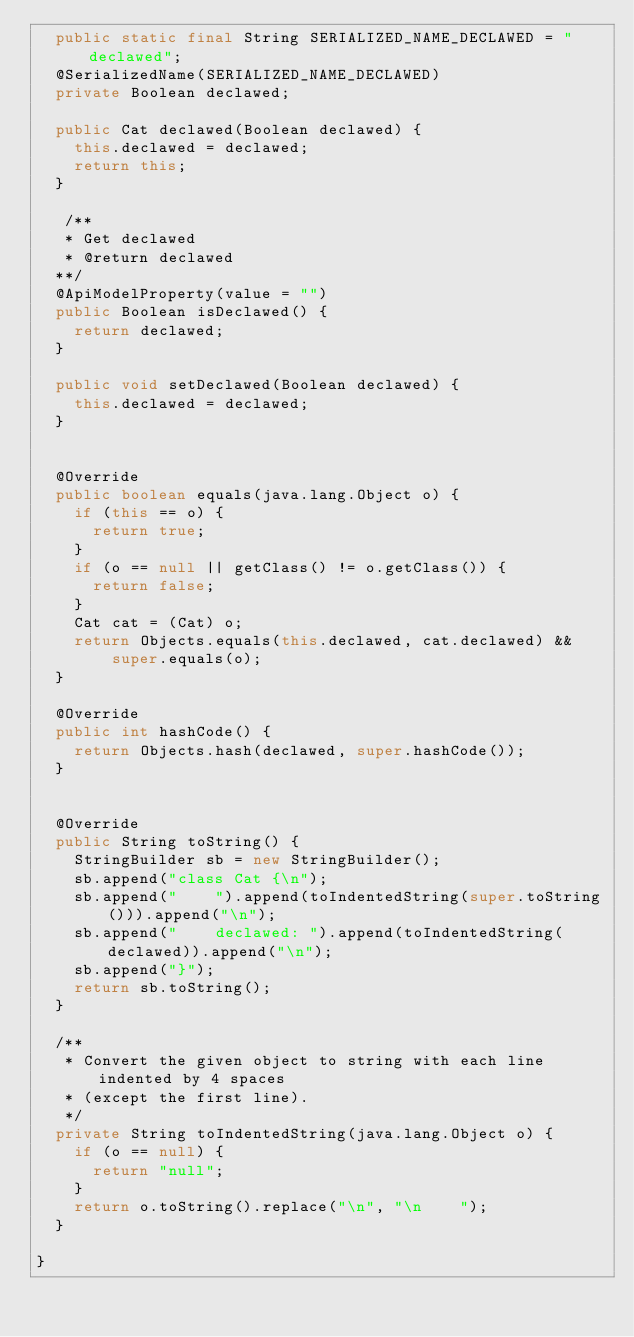Convert code to text. <code><loc_0><loc_0><loc_500><loc_500><_Java_>  public static final String SERIALIZED_NAME_DECLAWED = "declawed";
  @SerializedName(SERIALIZED_NAME_DECLAWED)
  private Boolean declawed;

  public Cat declawed(Boolean declawed) {
    this.declawed = declawed;
    return this;
  }

   /**
   * Get declawed
   * @return declawed
  **/
  @ApiModelProperty(value = "")
  public Boolean isDeclawed() {
    return declawed;
  }

  public void setDeclawed(Boolean declawed) {
    this.declawed = declawed;
  }


  @Override
  public boolean equals(java.lang.Object o) {
    if (this == o) {
      return true;
    }
    if (o == null || getClass() != o.getClass()) {
      return false;
    }
    Cat cat = (Cat) o;
    return Objects.equals(this.declawed, cat.declawed) &&
        super.equals(o);
  }

  @Override
  public int hashCode() {
    return Objects.hash(declawed, super.hashCode());
  }


  @Override
  public String toString() {
    StringBuilder sb = new StringBuilder();
    sb.append("class Cat {\n");
    sb.append("    ").append(toIndentedString(super.toString())).append("\n");
    sb.append("    declawed: ").append(toIndentedString(declawed)).append("\n");
    sb.append("}");
    return sb.toString();
  }

  /**
   * Convert the given object to string with each line indented by 4 spaces
   * (except the first line).
   */
  private String toIndentedString(java.lang.Object o) {
    if (o == null) {
      return "null";
    }
    return o.toString().replace("\n", "\n    ");
  }

}

</code> 